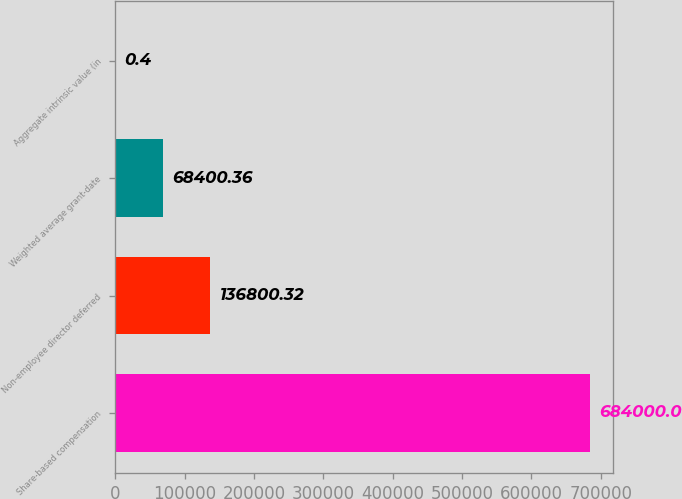Convert chart. <chart><loc_0><loc_0><loc_500><loc_500><bar_chart><fcel>Share-based compensation<fcel>Non-employee director deferred<fcel>Weighted average grant-date<fcel>Aggregate intrinsic value (in<nl><fcel>684000<fcel>136800<fcel>68400.4<fcel>0.4<nl></chart> 